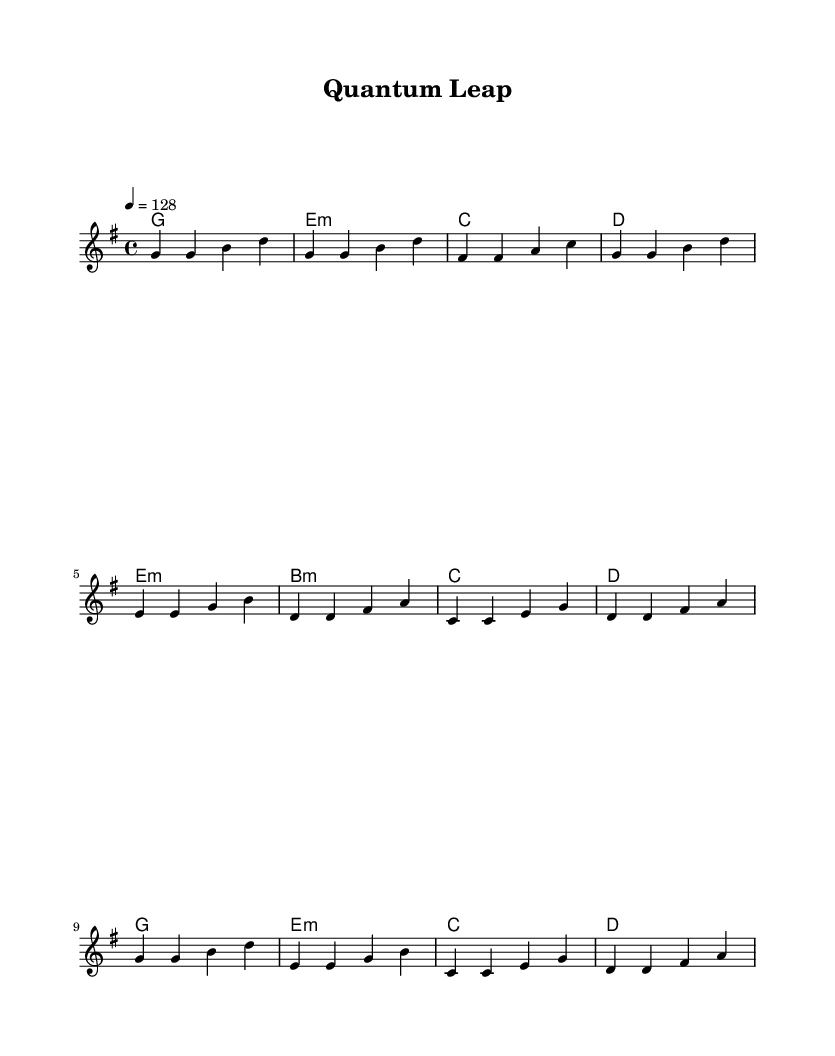What is the key signature of this music? The key signature is G major, which has one sharp (F#). This can be determined by looking at the key signature indication in the sheet music, which shows a single sharp.
Answer: G major What is the time signature of this music? The time signature is 4/4, as indicated at the beginning of the score. This means there are four beats in each measure, and the quarter note gets one beat.
Answer: 4/4 What is the tempo marking for this music? The tempo marking is 128 beats per minute, indicated by the marking "4 = 128" in the tempo section at the beginning of the score.
Answer: 128 How many distinct sections are in the music? The music consists of three distinct sections: Verse, Pre-Chorus, and Chorus. These sections are clearly labeled and structured in the score.
Answer: Three What is the first chord used in the verse? The first chord in the verse is G major, which is indicated at the beginning of the verse section on the chord line.
Answer: G Which section contains the most melodic variation? The Pre-Chorus contains more varied melodic patterns compared to the other sections, as it introduces different notes and intervals that are distinct from the Verse and Chorus.
Answer: Pre-Chorus What unique feature does K-Pop music often incorporate in terms of structure? K-Pop music often incorporates repeated catchy choruses that emphasize memorable hooks, which is evident in the structure of the score where the chorus is repeated after the verse and pre-chorus.
Answer: Repeated catchy choruses 